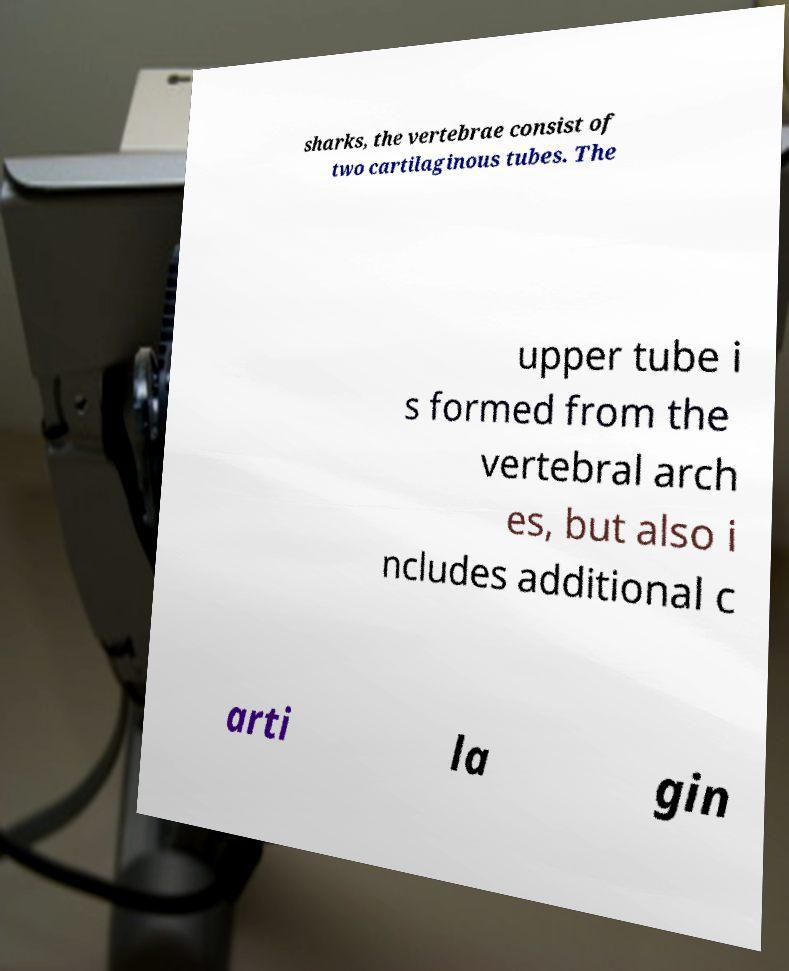I need the written content from this picture converted into text. Can you do that? sharks, the vertebrae consist of two cartilaginous tubes. The upper tube i s formed from the vertebral arch es, but also i ncludes additional c arti la gin 